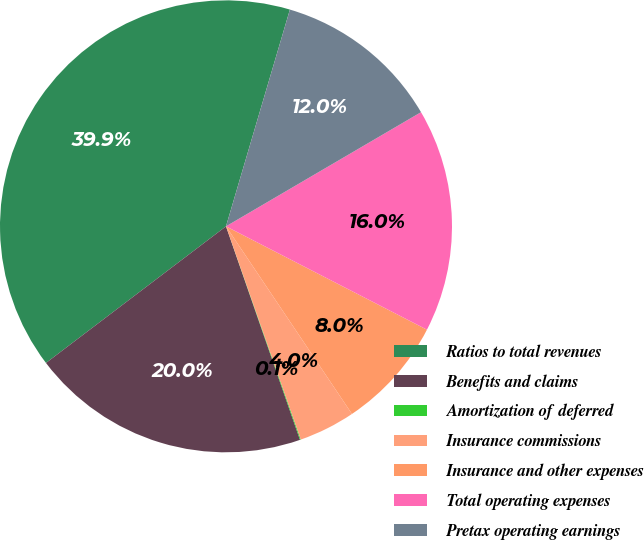Convert chart to OTSL. <chart><loc_0><loc_0><loc_500><loc_500><pie_chart><fcel>Ratios to total revenues<fcel>Benefits and claims<fcel>Amortization of deferred<fcel>Insurance commissions<fcel>Insurance and other expenses<fcel>Total operating expenses<fcel>Pretax operating earnings<nl><fcel>39.9%<fcel>19.98%<fcel>0.06%<fcel>4.04%<fcel>8.03%<fcel>15.99%<fcel>12.01%<nl></chart> 